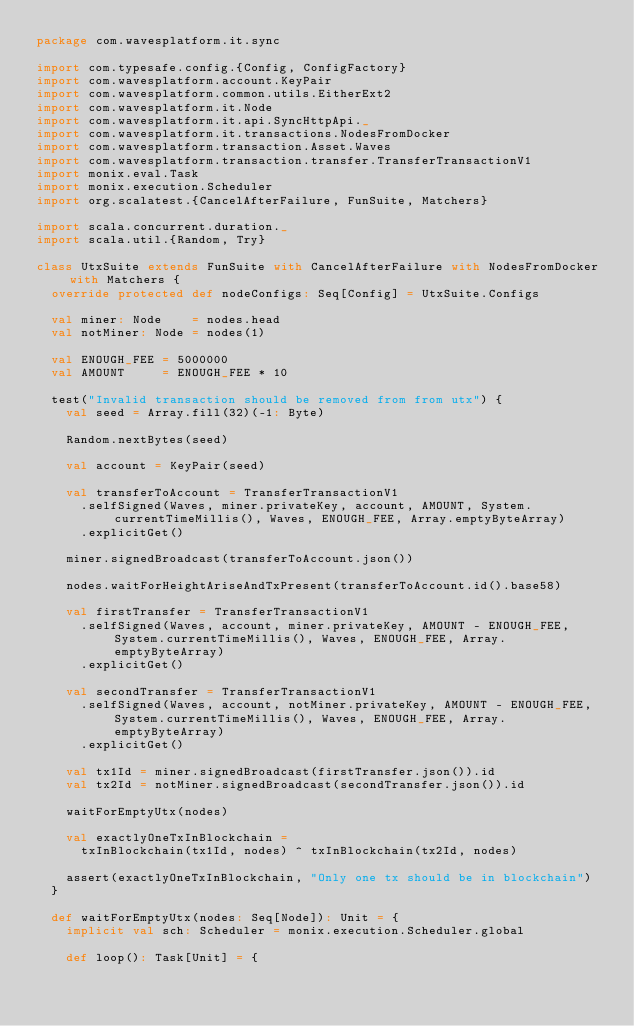Convert code to text. <code><loc_0><loc_0><loc_500><loc_500><_Scala_>package com.wavesplatform.it.sync

import com.typesafe.config.{Config, ConfigFactory}
import com.wavesplatform.account.KeyPair
import com.wavesplatform.common.utils.EitherExt2
import com.wavesplatform.it.Node
import com.wavesplatform.it.api.SyncHttpApi._
import com.wavesplatform.it.transactions.NodesFromDocker
import com.wavesplatform.transaction.Asset.Waves
import com.wavesplatform.transaction.transfer.TransferTransactionV1
import monix.eval.Task
import monix.execution.Scheduler
import org.scalatest.{CancelAfterFailure, FunSuite, Matchers}

import scala.concurrent.duration._
import scala.util.{Random, Try}

class UtxSuite extends FunSuite with CancelAfterFailure with NodesFromDocker with Matchers {
  override protected def nodeConfigs: Seq[Config] = UtxSuite.Configs

  val miner: Node    = nodes.head
  val notMiner: Node = nodes(1)

  val ENOUGH_FEE = 5000000
  val AMOUNT     = ENOUGH_FEE * 10

  test("Invalid transaction should be removed from from utx") {
    val seed = Array.fill(32)(-1: Byte)

    Random.nextBytes(seed)

    val account = KeyPair(seed)

    val transferToAccount = TransferTransactionV1
      .selfSigned(Waves, miner.privateKey, account, AMOUNT, System.currentTimeMillis(), Waves, ENOUGH_FEE, Array.emptyByteArray)
      .explicitGet()

    miner.signedBroadcast(transferToAccount.json())

    nodes.waitForHeightAriseAndTxPresent(transferToAccount.id().base58)

    val firstTransfer = TransferTransactionV1
      .selfSigned(Waves, account, miner.privateKey, AMOUNT - ENOUGH_FEE, System.currentTimeMillis(), Waves, ENOUGH_FEE, Array.emptyByteArray)
      .explicitGet()

    val secondTransfer = TransferTransactionV1
      .selfSigned(Waves, account, notMiner.privateKey, AMOUNT - ENOUGH_FEE, System.currentTimeMillis(), Waves, ENOUGH_FEE, Array.emptyByteArray)
      .explicitGet()

    val tx1Id = miner.signedBroadcast(firstTransfer.json()).id
    val tx2Id = notMiner.signedBroadcast(secondTransfer.json()).id

    waitForEmptyUtx(nodes)

    val exactlyOneTxInBlockchain =
      txInBlockchain(tx1Id, nodes) ^ txInBlockchain(tx2Id, nodes)

    assert(exactlyOneTxInBlockchain, "Only one tx should be in blockchain")
  }

  def waitForEmptyUtx(nodes: Seq[Node]): Unit = {
    implicit val sch: Scheduler = monix.execution.Scheduler.global

    def loop(): Task[Unit] = {</code> 